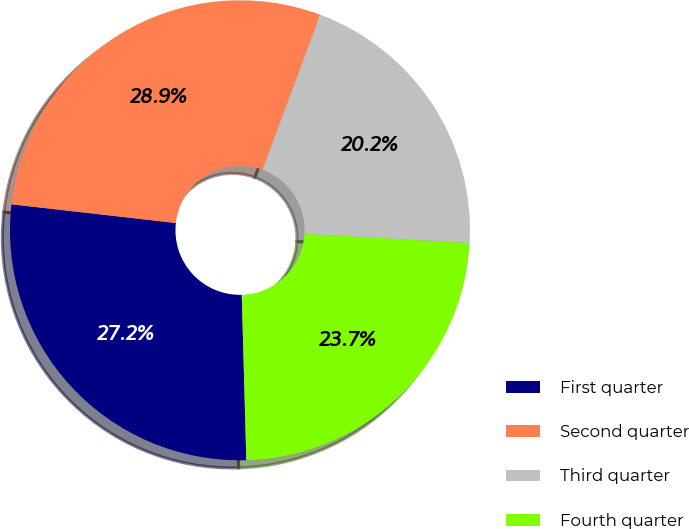Convert chart. <chart><loc_0><loc_0><loc_500><loc_500><pie_chart><fcel>First quarter<fcel>Second quarter<fcel>Third quarter<fcel>Fourth quarter<nl><fcel>27.24%<fcel>28.87%<fcel>20.21%<fcel>23.68%<nl></chart> 